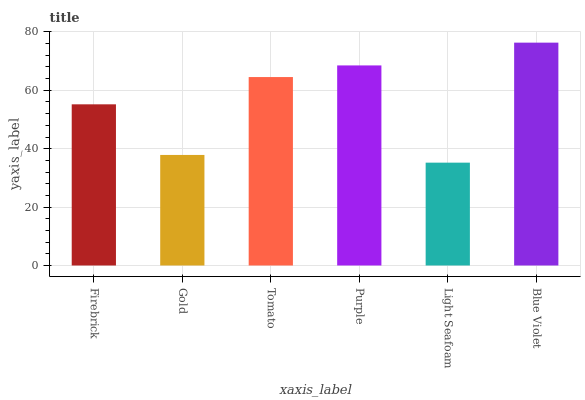Is Light Seafoam the minimum?
Answer yes or no. Yes. Is Blue Violet the maximum?
Answer yes or no. Yes. Is Gold the minimum?
Answer yes or no. No. Is Gold the maximum?
Answer yes or no. No. Is Firebrick greater than Gold?
Answer yes or no. Yes. Is Gold less than Firebrick?
Answer yes or no. Yes. Is Gold greater than Firebrick?
Answer yes or no. No. Is Firebrick less than Gold?
Answer yes or no. No. Is Tomato the high median?
Answer yes or no. Yes. Is Firebrick the low median?
Answer yes or no. Yes. Is Gold the high median?
Answer yes or no. No. Is Blue Violet the low median?
Answer yes or no. No. 